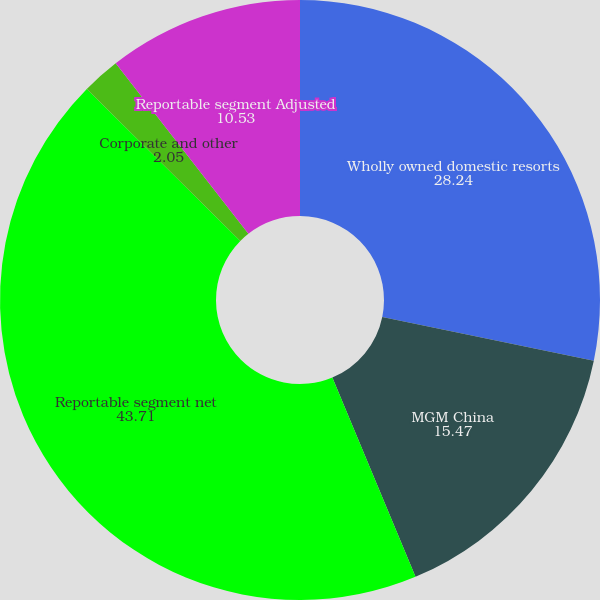<chart> <loc_0><loc_0><loc_500><loc_500><pie_chart><fcel>Wholly owned domestic resorts<fcel>MGM China<fcel>Reportable segment net<fcel>Corporate and other<fcel>Reportable segment Adjusted<nl><fcel>28.24%<fcel>15.47%<fcel>43.71%<fcel>2.05%<fcel>10.53%<nl></chart> 